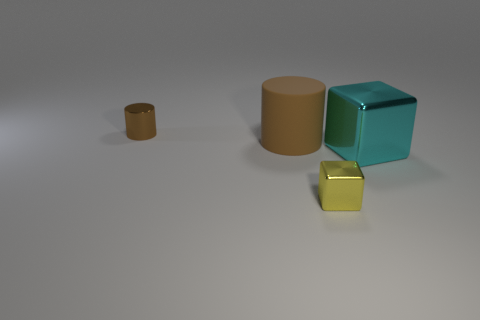What material is the large cyan thing that is the same shape as the yellow shiny thing?
Provide a succinct answer. Metal. What number of shiny things are either red cubes or small cylinders?
Offer a terse response. 1. There is a yellow thing that is made of the same material as the small brown object; what shape is it?
Your answer should be compact. Cube. What number of tiny metallic things are the same shape as the large brown object?
Provide a succinct answer. 1. There is a small object to the right of the tiny cylinder; is it the same shape as the brown object on the left side of the large matte object?
Provide a succinct answer. No. How many things are either big blue rubber spheres or cyan objects right of the small yellow metallic object?
Make the answer very short. 1. What shape is the other object that is the same color as the big matte object?
Offer a very short reply. Cylinder. What number of brown metal cylinders have the same size as the cyan object?
Provide a short and direct response. 0. What number of red things are blocks or metallic things?
Offer a very short reply. 0. There is a tiny thing behind the big thing right of the yellow thing; what shape is it?
Provide a short and direct response. Cylinder. 